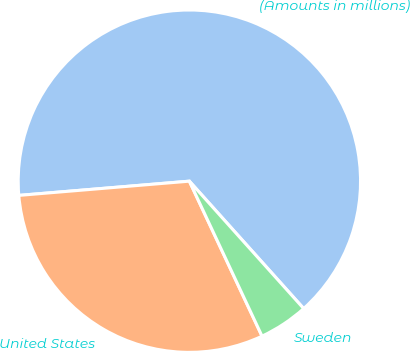Convert chart to OTSL. <chart><loc_0><loc_0><loc_500><loc_500><pie_chart><fcel>(Amounts in millions)<fcel>United States<fcel>Sweden<nl><fcel>64.68%<fcel>30.65%<fcel>4.66%<nl></chart> 